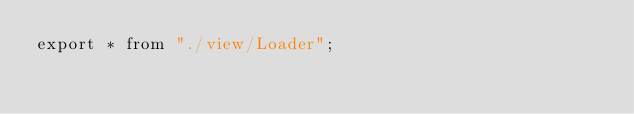<code> <loc_0><loc_0><loc_500><loc_500><_TypeScript_>export * from "./view/Loader";
</code> 